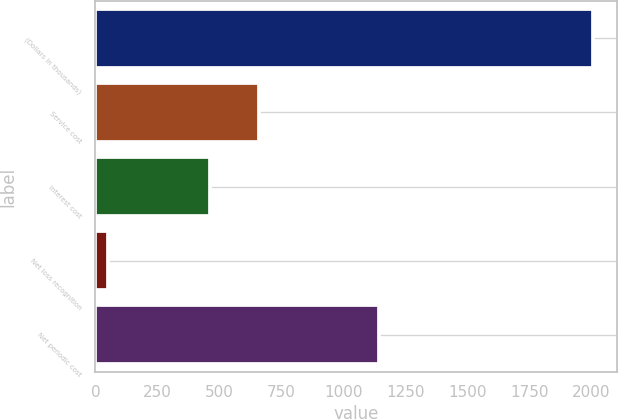<chart> <loc_0><loc_0><loc_500><loc_500><bar_chart><fcel>(Dollars in thousands)<fcel>Service cost<fcel>Interest cost<fcel>Net loss recognition<fcel>Net periodic cost<nl><fcel>2006<fcel>659.6<fcel>464<fcel>50<fcel>1145<nl></chart> 